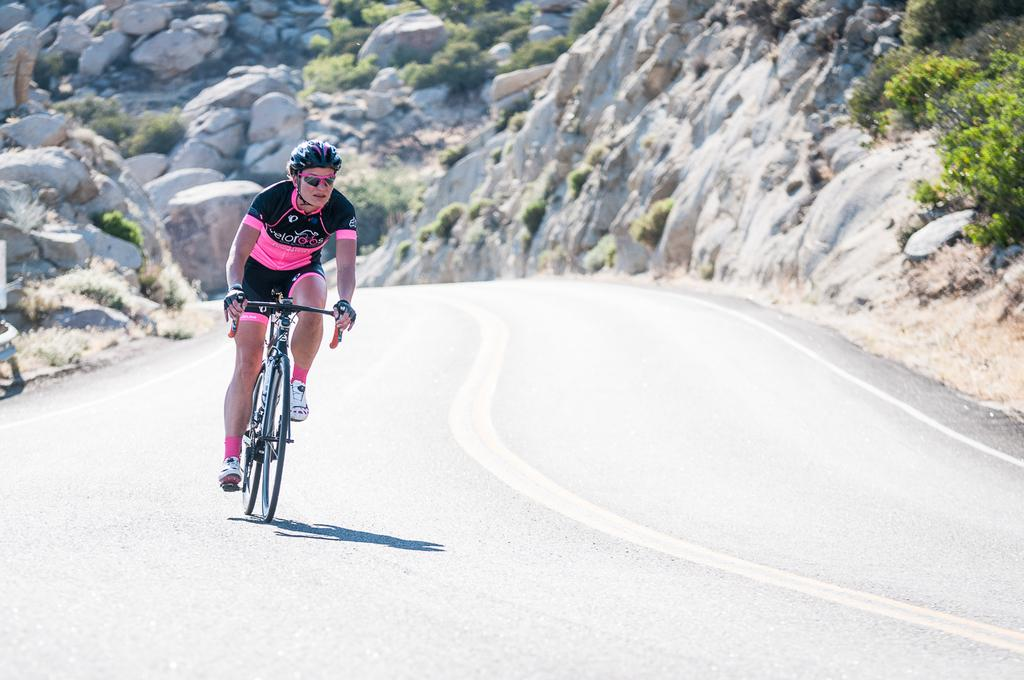What is the person in the image doing? The person is riding a bicycle in the image. What safety precaution is the person taking while riding the bicycle? The person is wearing a helmet. What type of surface is visible at the bottom of the image? There is a road at the bottom of the image. What can be seen in the background of the image? There are stones and plants in the background of the image. What type of box is being transported by the person on the bicycle in the image? There is no box visible in the image; the person is simply riding a bicycle. 